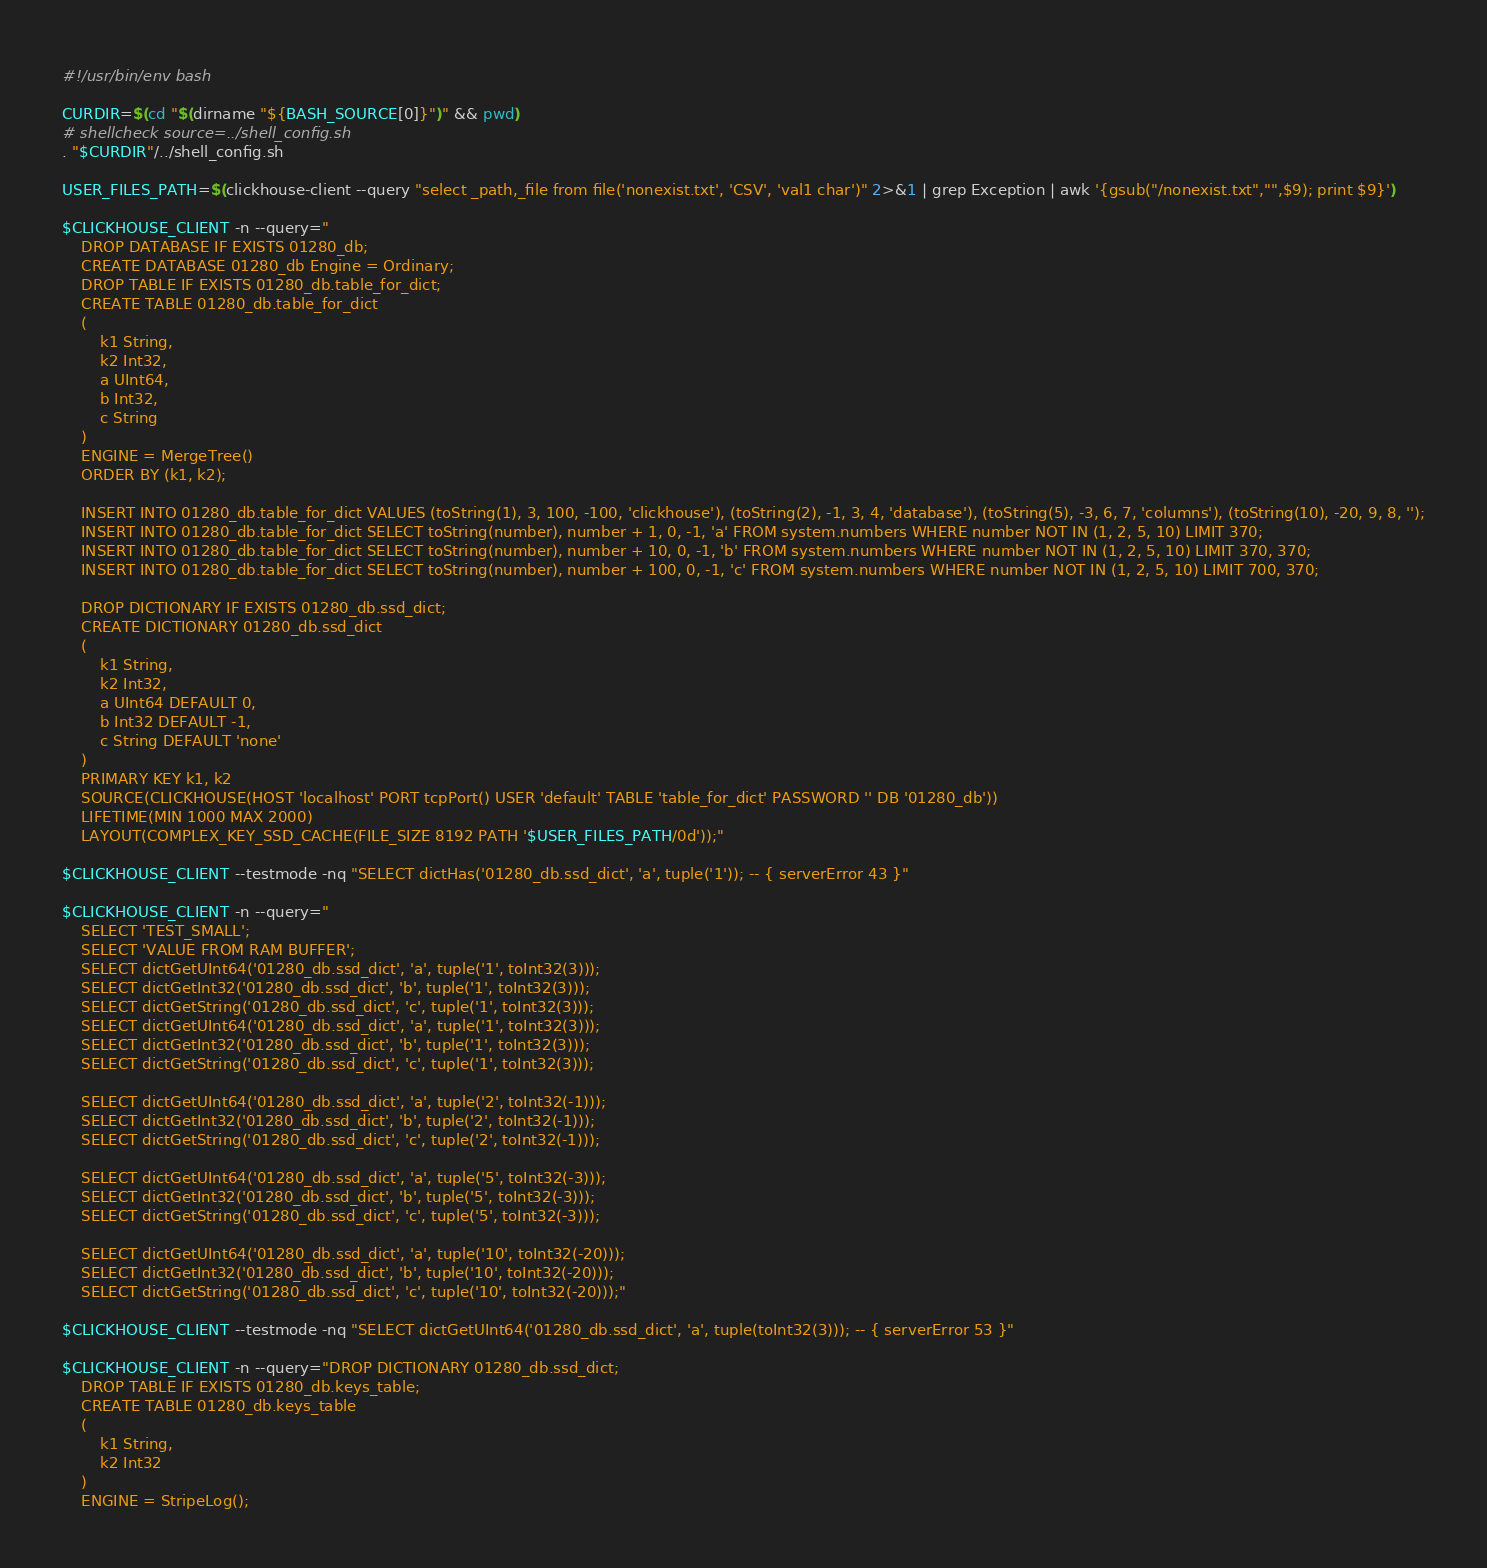<code> <loc_0><loc_0><loc_500><loc_500><_Bash_>#!/usr/bin/env bash

CURDIR=$(cd "$(dirname "${BASH_SOURCE[0]}")" && pwd)
# shellcheck source=../shell_config.sh
. "$CURDIR"/../shell_config.sh

USER_FILES_PATH=$(clickhouse-client --query "select _path,_file from file('nonexist.txt', 'CSV', 'val1 char')" 2>&1 | grep Exception | awk '{gsub("/nonexist.txt","",$9); print $9}')

$CLICKHOUSE_CLIENT -n --query="
    DROP DATABASE IF EXISTS 01280_db;
    CREATE DATABASE 01280_db Engine = Ordinary;
    DROP TABLE IF EXISTS 01280_db.table_for_dict;
    CREATE TABLE 01280_db.table_for_dict
    (
        k1 String,
        k2 Int32,
        a UInt64,
        b Int32,
        c String
    )
    ENGINE = MergeTree()
    ORDER BY (k1, k2);

    INSERT INTO 01280_db.table_for_dict VALUES (toString(1), 3, 100, -100, 'clickhouse'), (toString(2), -1, 3, 4, 'database'), (toString(5), -3, 6, 7, 'columns'), (toString(10), -20, 9, 8, '');
    INSERT INTO 01280_db.table_for_dict SELECT toString(number), number + 1, 0, -1, 'a' FROM system.numbers WHERE number NOT IN (1, 2, 5, 10) LIMIT 370;
    INSERT INTO 01280_db.table_for_dict SELECT toString(number), number + 10, 0, -1, 'b' FROM system.numbers WHERE number NOT IN (1, 2, 5, 10) LIMIT 370, 370;
    INSERT INTO 01280_db.table_for_dict SELECT toString(number), number + 100, 0, -1, 'c' FROM system.numbers WHERE number NOT IN (1, 2, 5, 10) LIMIT 700, 370;

    DROP DICTIONARY IF EXISTS 01280_db.ssd_dict;
    CREATE DICTIONARY 01280_db.ssd_dict
    (
        k1 String,
        k2 Int32,
        a UInt64 DEFAULT 0,
        b Int32 DEFAULT -1,
        c String DEFAULT 'none'
    )
    PRIMARY KEY k1, k2
    SOURCE(CLICKHOUSE(HOST 'localhost' PORT tcpPort() USER 'default' TABLE 'table_for_dict' PASSWORD '' DB '01280_db'))
    LIFETIME(MIN 1000 MAX 2000)
    LAYOUT(COMPLEX_KEY_SSD_CACHE(FILE_SIZE 8192 PATH '$USER_FILES_PATH/0d'));"

$CLICKHOUSE_CLIENT --testmode -nq "SELECT dictHas('01280_db.ssd_dict', 'a', tuple('1')); -- { serverError 43 }"

$CLICKHOUSE_CLIENT -n --query="
    SELECT 'TEST_SMALL';
    SELECT 'VALUE FROM RAM BUFFER';
    SELECT dictGetUInt64('01280_db.ssd_dict', 'a', tuple('1', toInt32(3)));
    SELECT dictGetInt32('01280_db.ssd_dict', 'b', tuple('1', toInt32(3)));
    SELECT dictGetString('01280_db.ssd_dict', 'c', tuple('1', toInt32(3)));
    SELECT dictGetUInt64('01280_db.ssd_dict', 'a', tuple('1', toInt32(3)));
    SELECT dictGetInt32('01280_db.ssd_dict', 'b', tuple('1', toInt32(3)));
    SELECT dictGetString('01280_db.ssd_dict', 'c', tuple('1', toInt32(3)));

    SELECT dictGetUInt64('01280_db.ssd_dict', 'a', tuple('2', toInt32(-1)));
    SELECT dictGetInt32('01280_db.ssd_dict', 'b', tuple('2', toInt32(-1)));
    SELECT dictGetString('01280_db.ssd_dict', 'c', tuple('2', toInt32(-1)));

    SELECT dictGetUInt64('01280_db.ssd_dict', 'a', tuple('5', toInt32(-3)));
    SELECT dictGetInt32('01280_db.ssd_dict', 'b', tuple('5', toInt32(-3)));
    SELECT dictGetString('01280_db.ssd_dict', 'c', tuple('5', toInt32(-3)));

    SELECT dictGetUInt64('01280_db.ssd_dict', 'a', tuple('10', toInt32(-20)));
    SELECT dictGetInt32('01280_db.ssd_dict', 'b', tuple('10', toInt32(-20)));
    SELECT dictGetString('01280_db.ssd_dict', 'c', tuple('10', toInt32(-20)));"

$CLICKHOUSE_CLIENT --testmode -nq "SELECT dictGetUInt64('01280_db.ssd_dict', 'a', tuple(toInt32(3))); -- { serverError 53 }"

$CLICKHOUSE_CLIENT -n --query="DROP DICTIONARY 01280_db.ssd_dict;
    DROP TABLE IF EXISTS 01280_db.keys_table;
    CREATE TABLE 01280_db.keys_table
    (
        k1 String,
        k2 Int32
    )
    ENGINE = StripeLog();
</code> 